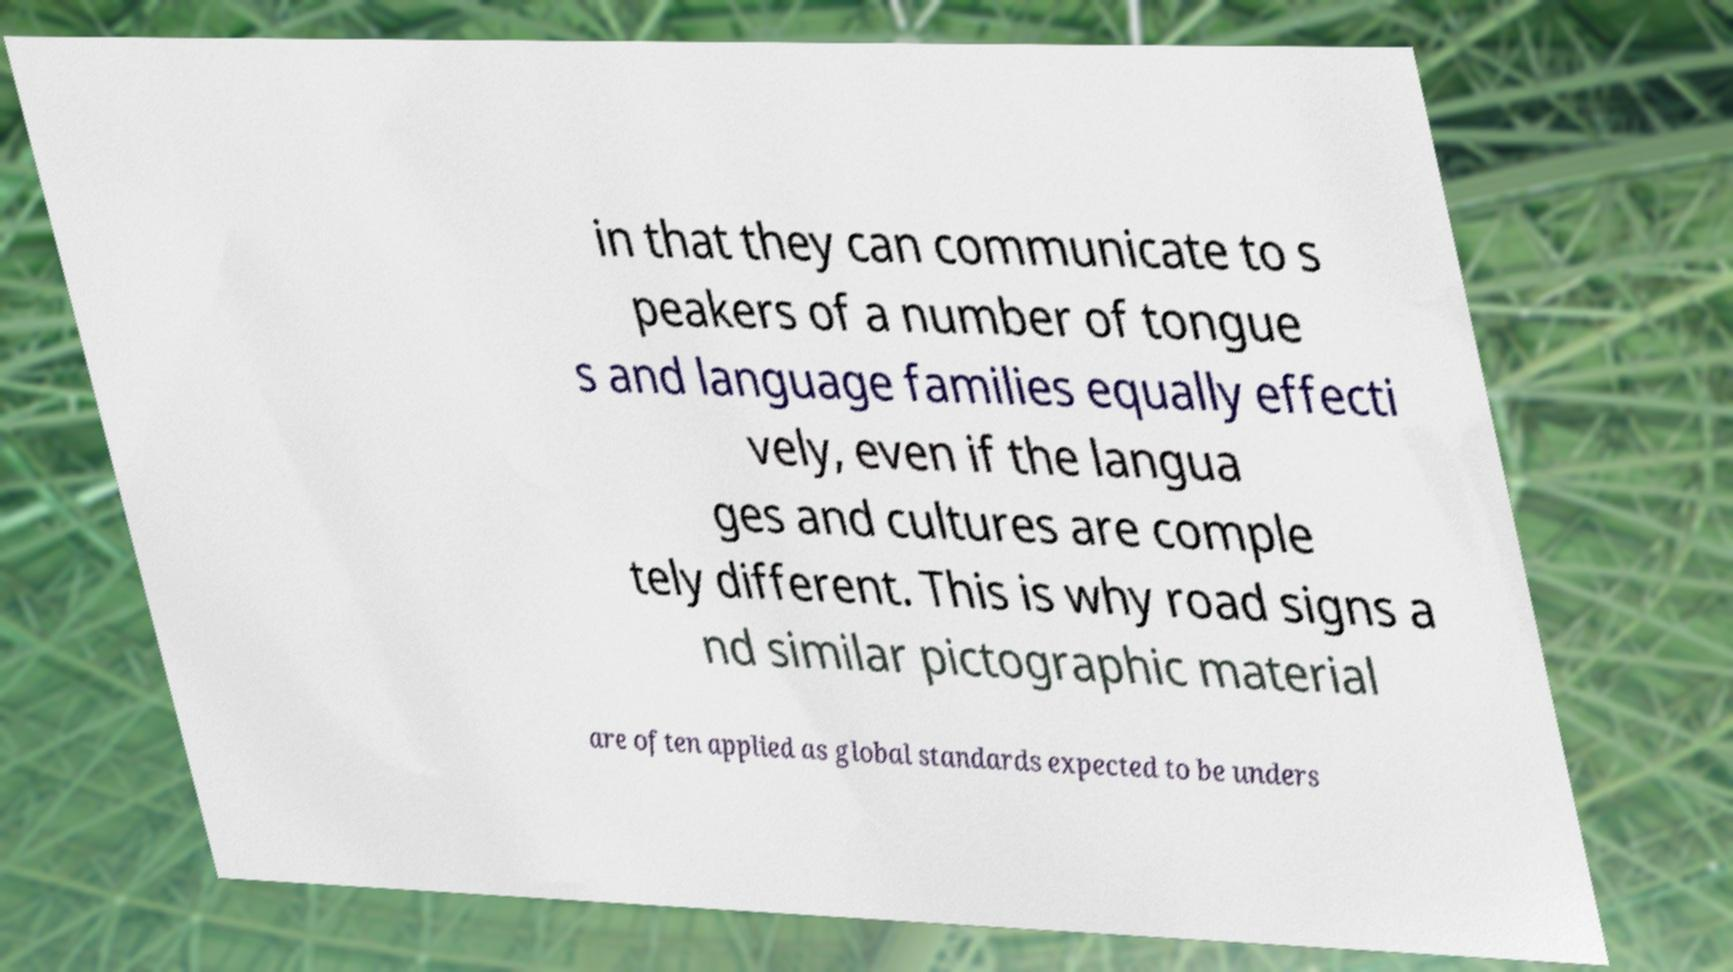Could you assist in decoding the text presented in this image and type it out clearly? in that they can communicate to s peakers of a number of tongue s and language families equally effecti vely, even if the langua ges and cultures are comple tely different. This is why road signs a nd similar pictographic material are often applied as global standards expected to be unders 